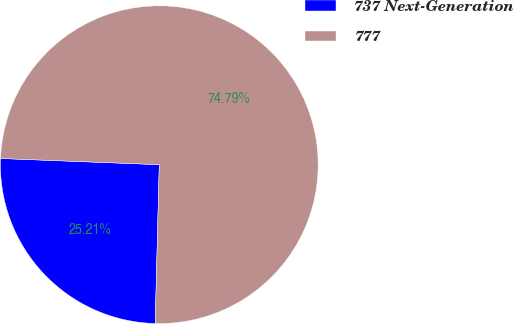Convert chart to OTSL. <chart><loc_0><loc_0><loc_500><loc_500><pie_chart><fcel>737 Next-Generation<fcel>777<nl><fcel>25.21%<fcel>74.79%<nl></chart> 